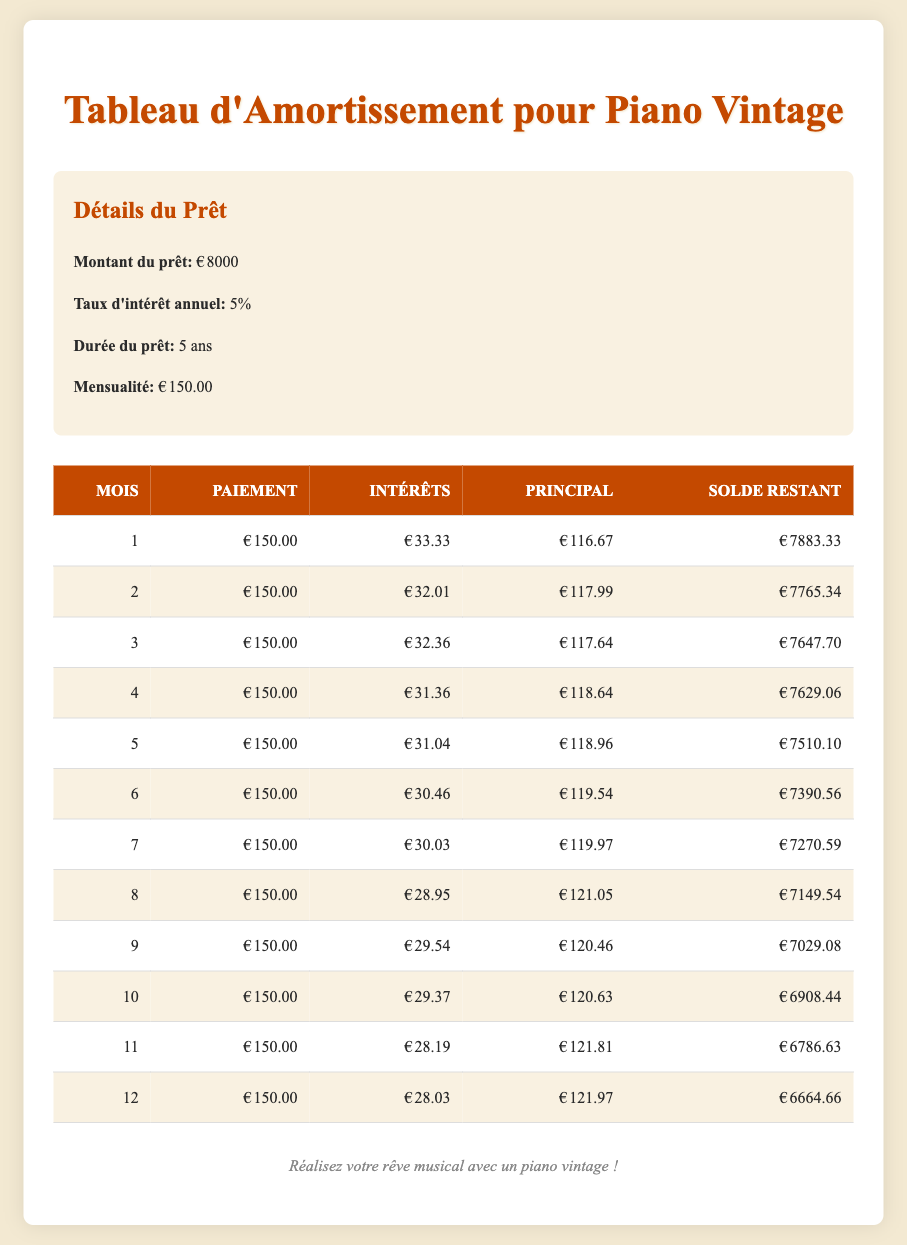What is the total interest paid in the first three months? To find the total interest paid in the first three months, we sum the interest paid for each of those months: 33.33 (month 1) + 32.01 (month 2) + 32.36 (month 3) = 97.70.
Answer: 97.70 What is the remaining balance after the 5th payment? According to the table, the remaining balance after the 5th payment (month 5) is 7510.10.
Answer: 7510.10 Did the interest paid decrease in the first three months? By examining the interest paid: 33.33 (month 1), 32.01 (month 2), and 32.36 (month 3), we see that 33.33 > 32.01 and 32.01 < 32.36, so the interest decreased from the first to the second month, but increased from the second to the third month. Therefore, the overall trend is not consistently decreasing.
Answer: No What is the average principal paid per month in the first 12 months? To calculate the average principal paid per month, we first need to sum the principal paid for each month, which adds up to 1,448.70 (summing individual principal amounts) and divide by 12 months. This gives us an average of 1,448.70 / 12 = 120.72.
Answer: 120.72 How much did the principal paid in the 8th month compare to the interest paid in the same month? In the 8th month, the principal paid is 121.05, while the interest paid is 28.95. To compare, we subtract the interest from the principal: 121.05 - 28.95 = 92.10, meaning the principal paid is 92.10 more than the interest paid.
Answer: 92.10 more What is the interest paid in the 12th month, and how does it relate to the total interest paid in the first 12 months? The interest paid in the 12th month is 28.03. To find out how it relates to the total interest paid in the first 12 months, we calculate that total first: 33.33 + 32.01 + 32.36 + 31.36 + 31.04 + 30.46 + 30.03 + 28.95 + 29.54 + 29.37 + 28.19 + 28.03 =  364.03. The 12th month's interest (28.03) is about 7.7% of the total interest (364.03), highlighting its relative amount.
Answer: 28.03; 7.7% How much principal was paid in total after the first six months? To calculate the total principal paid after six months, we sum the principal amounts for those months: 116.67 (month 1) + 117.99 (month 2) + 117.64 (month 3) + 118.64 (month 4) + 118.96 (month 5) + 119.54 (month 6) = 709.44.
Answer: 709.44 Is the monthly payment of 150.00 consistent throughout the term? We observe the payment column for all months, where each month shows a payment of 150.00. This consistency confirms that the payment remained the same each month.
Answer: Yes 